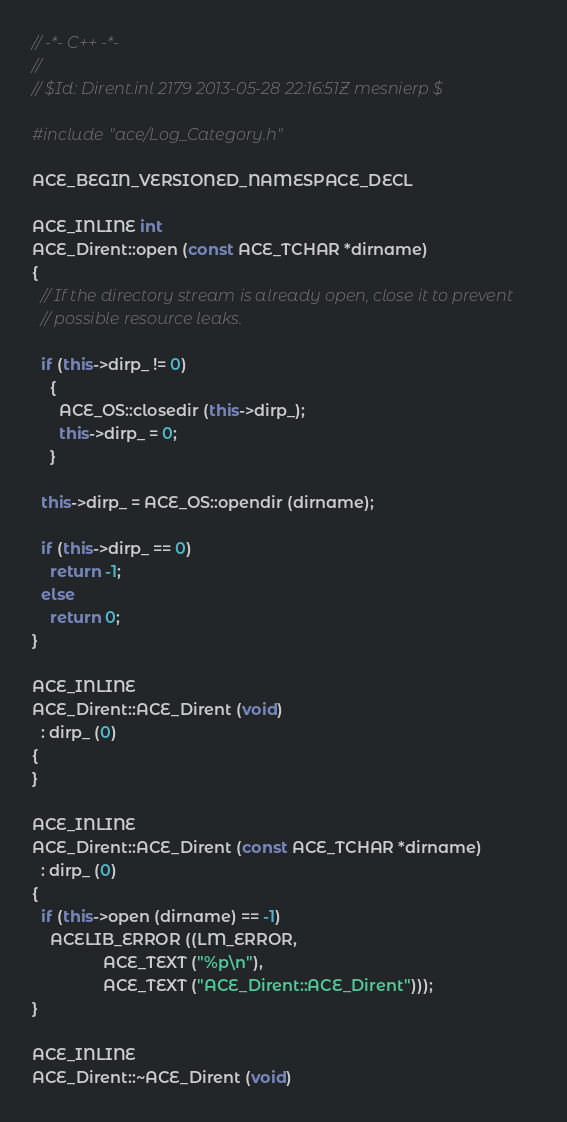Convert code to text. <code><loc_0><loc_0><loc_500><loc_500><_C++_>// -*- C++ -*-
//
// $Id: Dirent.inl 2179 2013-05-28 22:16:51Z mesnierp $

#include "ace/Log_Category.h"

ACE_BEGIN_VERSIONED_NAMESPACE_DECL

ACE_INLINE int
ACE_Dirent::open (const ACE_TCHAR *dirname)
{
  // If the directory stream is already open, close it to prevent
  // possible resource leaks.

  if (this->dirp_ != 0)
    {
      ACE_OS::closedir (this->dirp_);
      this->dirp_ = 0;
    }

  this->dirp_ = ACE_OS::opendir (dirname);

  if (this->dirp_ == 0)
    return -1;
  else
    return 0;
}

ACE_INLINE
ACE_Dirent::ACE_Dirent (void)
  : dirp_ (0)
{
}

ACE_INLINE
ACE_Dirent::ACE_Dirent (const ACE_TCHAR *dirname)
  : dirp_ (0)
{
  if (this->open (dirname) == -1)
    ACELIB_ERROR ((LM_ERROR,
                ACE_TEXT ("%p\n"),
                ACE_TEXT ("ACE_Dirent::ACE_Dirent")));
}

ACE_INLINE
ACE_Dirent::~ACE_Dirent (void)</code> 